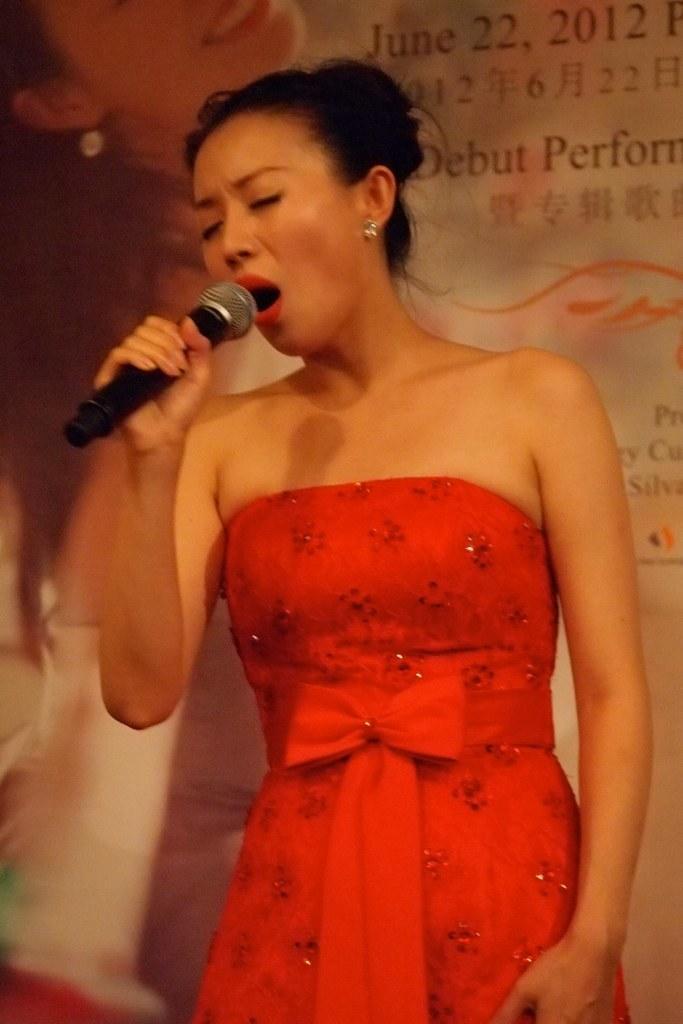Could you give a brief overview of what you see in this image? In the middle of the image a woman is standing and holding a microphone and singing. Behind her there is a banner. 